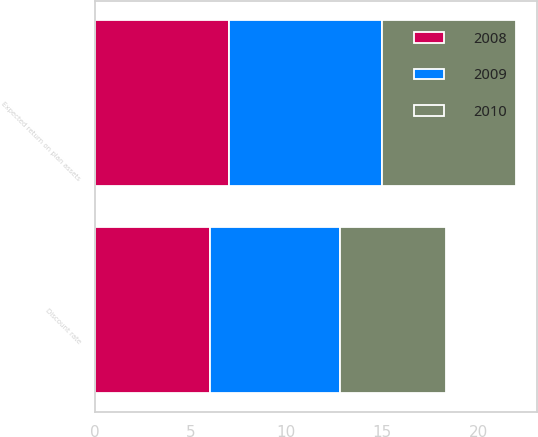<chart> <loc_0><loc_0><loc_500><loc_500><stacked_bar_chart><ecel><fcel>Discount rate<fcel>Expected return on plan assets<nl><fcel>2010<fcel>5.51<fcel>7<nl><fcel>2008<fcel>6.01<fcel>7<nl><fcel>2009<fcel>6.81<fcel>8<nl></chart> 